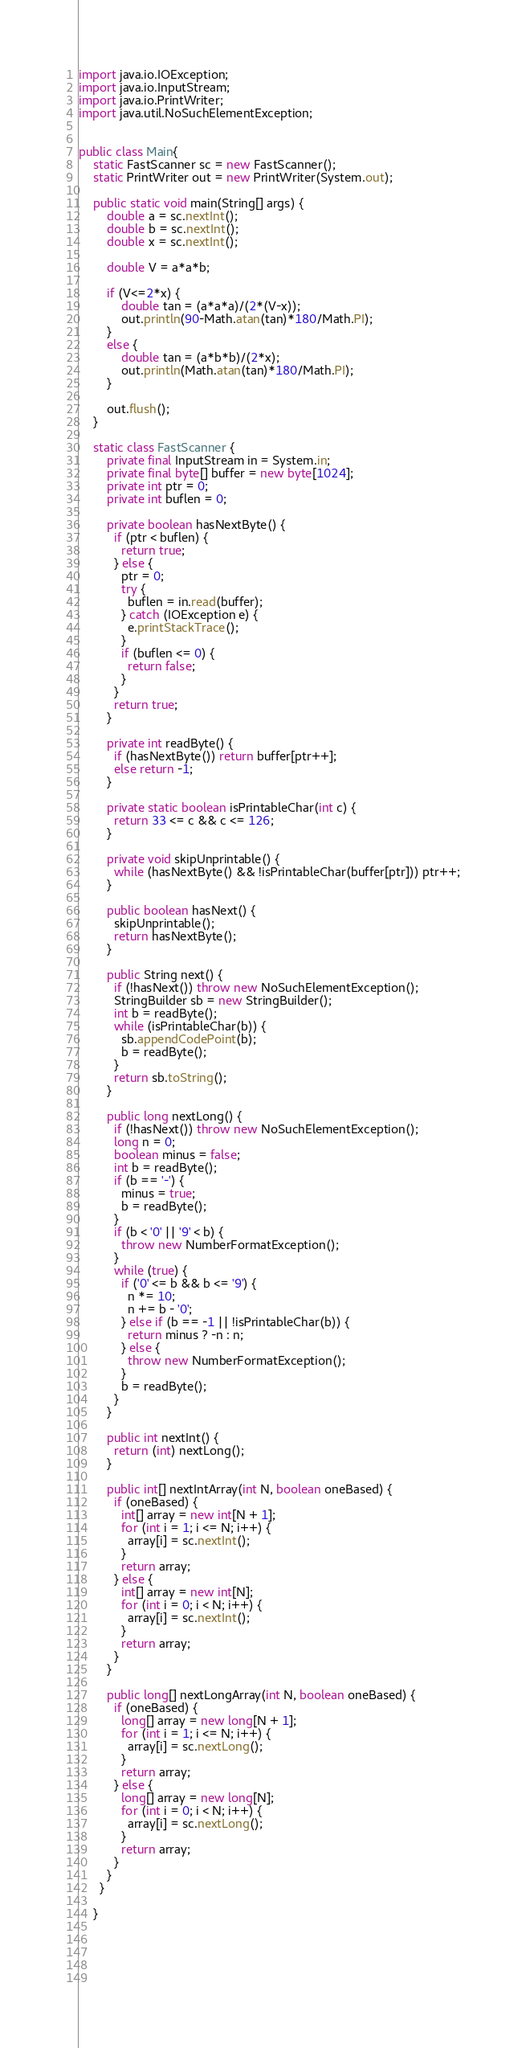Convert code to text. <code><loc_0><loc_0><loc_500><loc_500><_Java_>import java.io.IOException;
import java.io.InputStream;
import java.io.PrintWriter;
import java.util.NoSuchElementException;


public class Main{
	static FastScanner sc = new FastScanner();
	static PrintWriter out = new PrintWriter(System.out);
	
	public static void main(String[] args) {
		double a = sc.nextInt();
		double b = sc.nextInt();
		double x = sc.nextInt();
		
		double V = a*a*b;
		
		if (V<=2*x) {
			double tan = (a*a*a)/(2*(V-x));
			out.println(90-Math.atan(tan)*180/Math.PI);	
		}
		else {
			double tan = (a*b*b)/(2*x);
			out.println(Math.atan(tan)*180/Math.PI);	
		}
		
        out.flush();
	}
	
	static class FastScanner {
	    private final InputStream in = System.in;
	    private final byte[] buffer = new byte[1024];
	    private int ptr = 0;
	    private int buflen = 0;

	    private boolean hasNextByte() {
	      if (ptr < buflen) {
	        return true;
	      } else {
	        ptr = 0;
	        try {
	          buflen = in.read(buffer);
	        } catch (IOException e) {
	          e.printStackTrace();
	        }
	        if (buflen <= 0) {
	          return false;
	        }
	      }
	      return true;
	    }

	    private int readByte() {
	      if (hasNextByte()) return buffer[ptr++];
	      else return -1;
	    }

	    private static boolean isPrintableChar(int c) {
	      return 33 <= c && c <= 126;
	    }

	    private void skipUnprintable() {
	      while (hasNextByte() && !isPrintableChar(buffer[ptr])) ptr++;
	    }

	    public boolean hasNext() {
	      skipUnprintable();
	      return hasNextByte();
	    }

	    public String next() {
	      if (!hasNext()) throw new NoSuchElementException();
	      StringBuilder sb = new StringBuilder();
	      int b = readByte();
	      while (isPrintableChar(b)) {
	        sb.appendCodePoint(b);
	        b = readByte();
	      }
	      return sb.toString();
	    }

	    public long nextLong() {
	      if (!hasNext()) throw new NoSuchElementException();
	      long n = 0;
	      boolean minus = false;
	      int b = readByte();
	      if (b == '-') {
	        minus = true;
	        b = readByte();
	      }
	      if (b < '0' || '9' < b) {
	        throw new NumberFormatException();
	      }
	      while (true) {
	        if ('0' <= b && b <= '9') {
	          n *= 10;
	          n += b - '0';
	        } else if (b == -1 || !isPrintableChar(b)) {
	          return minus ? -n : n;
	        } else {
	          throw new NumberFormatException();
	        }
	        b = readByte();
	      }
	    }

	    public int nextInt() {
	      return (int) nextLong();
	    }

	    public int[] nextIntArray(int N, boolean oneBased) {
	      if (oneBased) {
	        int[] array = new int[N + 1];
	        for (int i = 1; i <= N; i++) {
	          array[i] = sc.nextInt();
	        }
	        return array;
	      } else {
	        int[] array = new int[N];
	        for (int i = 0; i < N; i++) {
	          array[i] = sc.nextInt();
	        }
	        return array;
	      }
	    }

	    public long[] nextLongArray(int N, boolean oneBased) {
	      if (oneBased) {
	        long[] array = new long[N + 1];
	        for (int i = 1; i <= N; i++) {
	          array[i] = sc.nextLong();
	        }
	        return array;
	      } else {
	        long[] array = new long[N];
	        for (int i = 0; i < N; i++) {
	          array[i] = sc.nextLong();
	        }
	        return array;
	      }
	    }
	  }

	}	 




		
</code> 